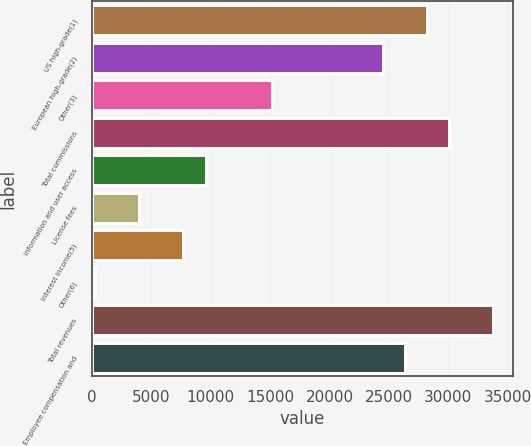Convert chart. <chart><loc_0><loc_0><loc_500><loc_500><bar_chart><fcel>US high-grade(1)<fcel>European high-grade(2)<fcel>Other(3)<fcel>Total commissions<fcel>Information and user access<fcel>License fees<fcel>Interest income(5)<fcel>Other(6)<fcel>Total revenues<fcel>Employee compensation and<nl><fcel>28192.5<fcel>24468.3<fcel>15157.8<fcel>30054.6<fcel>9571.5<fcel>3985.2<fcel>7709.4<fcel>261<fcel>33778.8<fcel>26330.4<nl></chart> 